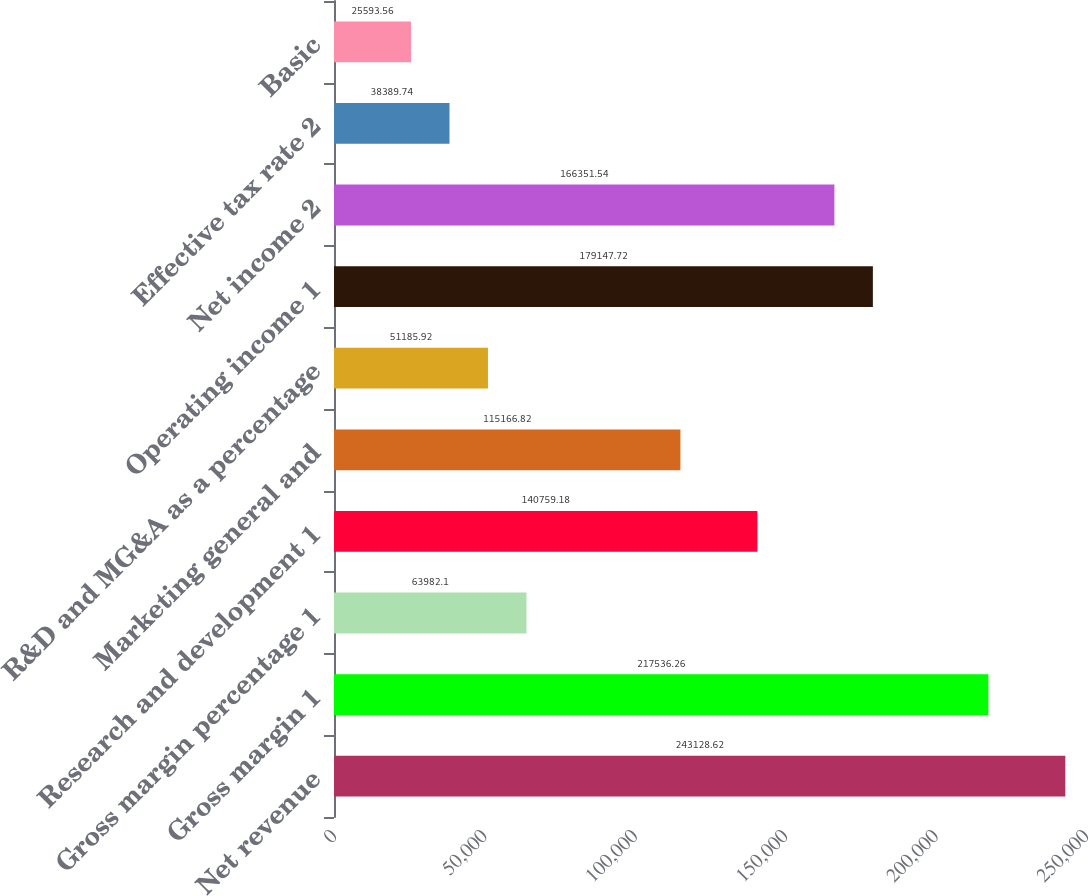<chart> <loc_0><loc_0><loc_500><loc_500><bar_chart><fcel>Net revenue<fcel>Gross margin 1<fcel>Gross margin percentage 1<fcel>Research and development 1<fcel>Marketing general and<fcel>R&D and MG&A as a percentage<fcel>Operating income 1<fcel>Net income 2<fcel>Effective tax rate 2<fcel>Basic<nl><fcel>243129<fcel>217536<fcel>63982.1<fcel>140759<fcel>115167<fcel>51185.9<fcel>179148<fcel>166352<fcel>38389.7<fcel>25593.6<nl></chart> 